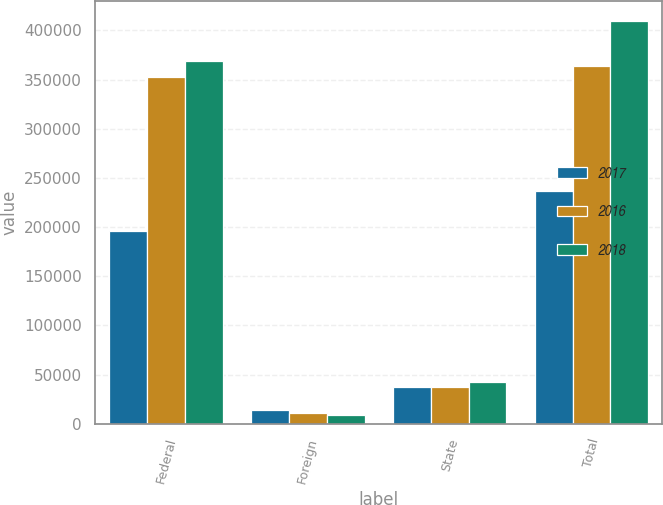Convert chart to OTSL. <chart><loc_0><loc_0><loc_500><loc_500><stacked_bar_chart><ecel><fcel>Federal<fcel>Foreign<fcel>State<fcel>Total<nl><fcel>2017<fcel>195862<fcel>13699<fcel>37555<fcel>236642<nl><fcel>2016<fcel>352433<fcel>10625<fcel>37421<fcel>363697<nl><fcel>2018<fcel>368957<fcel>8513<fcel>42166<fcel>409187<nl></chart> 